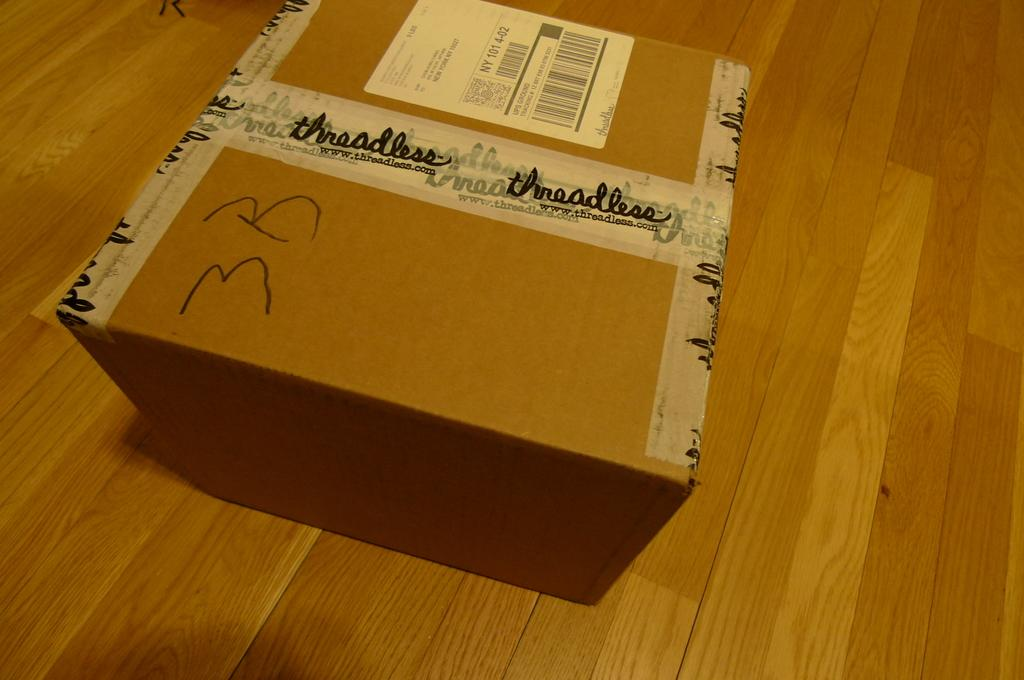<image>
Present a compact description of the photo's key features. A box with 3 B scrawled on the left hand of it 